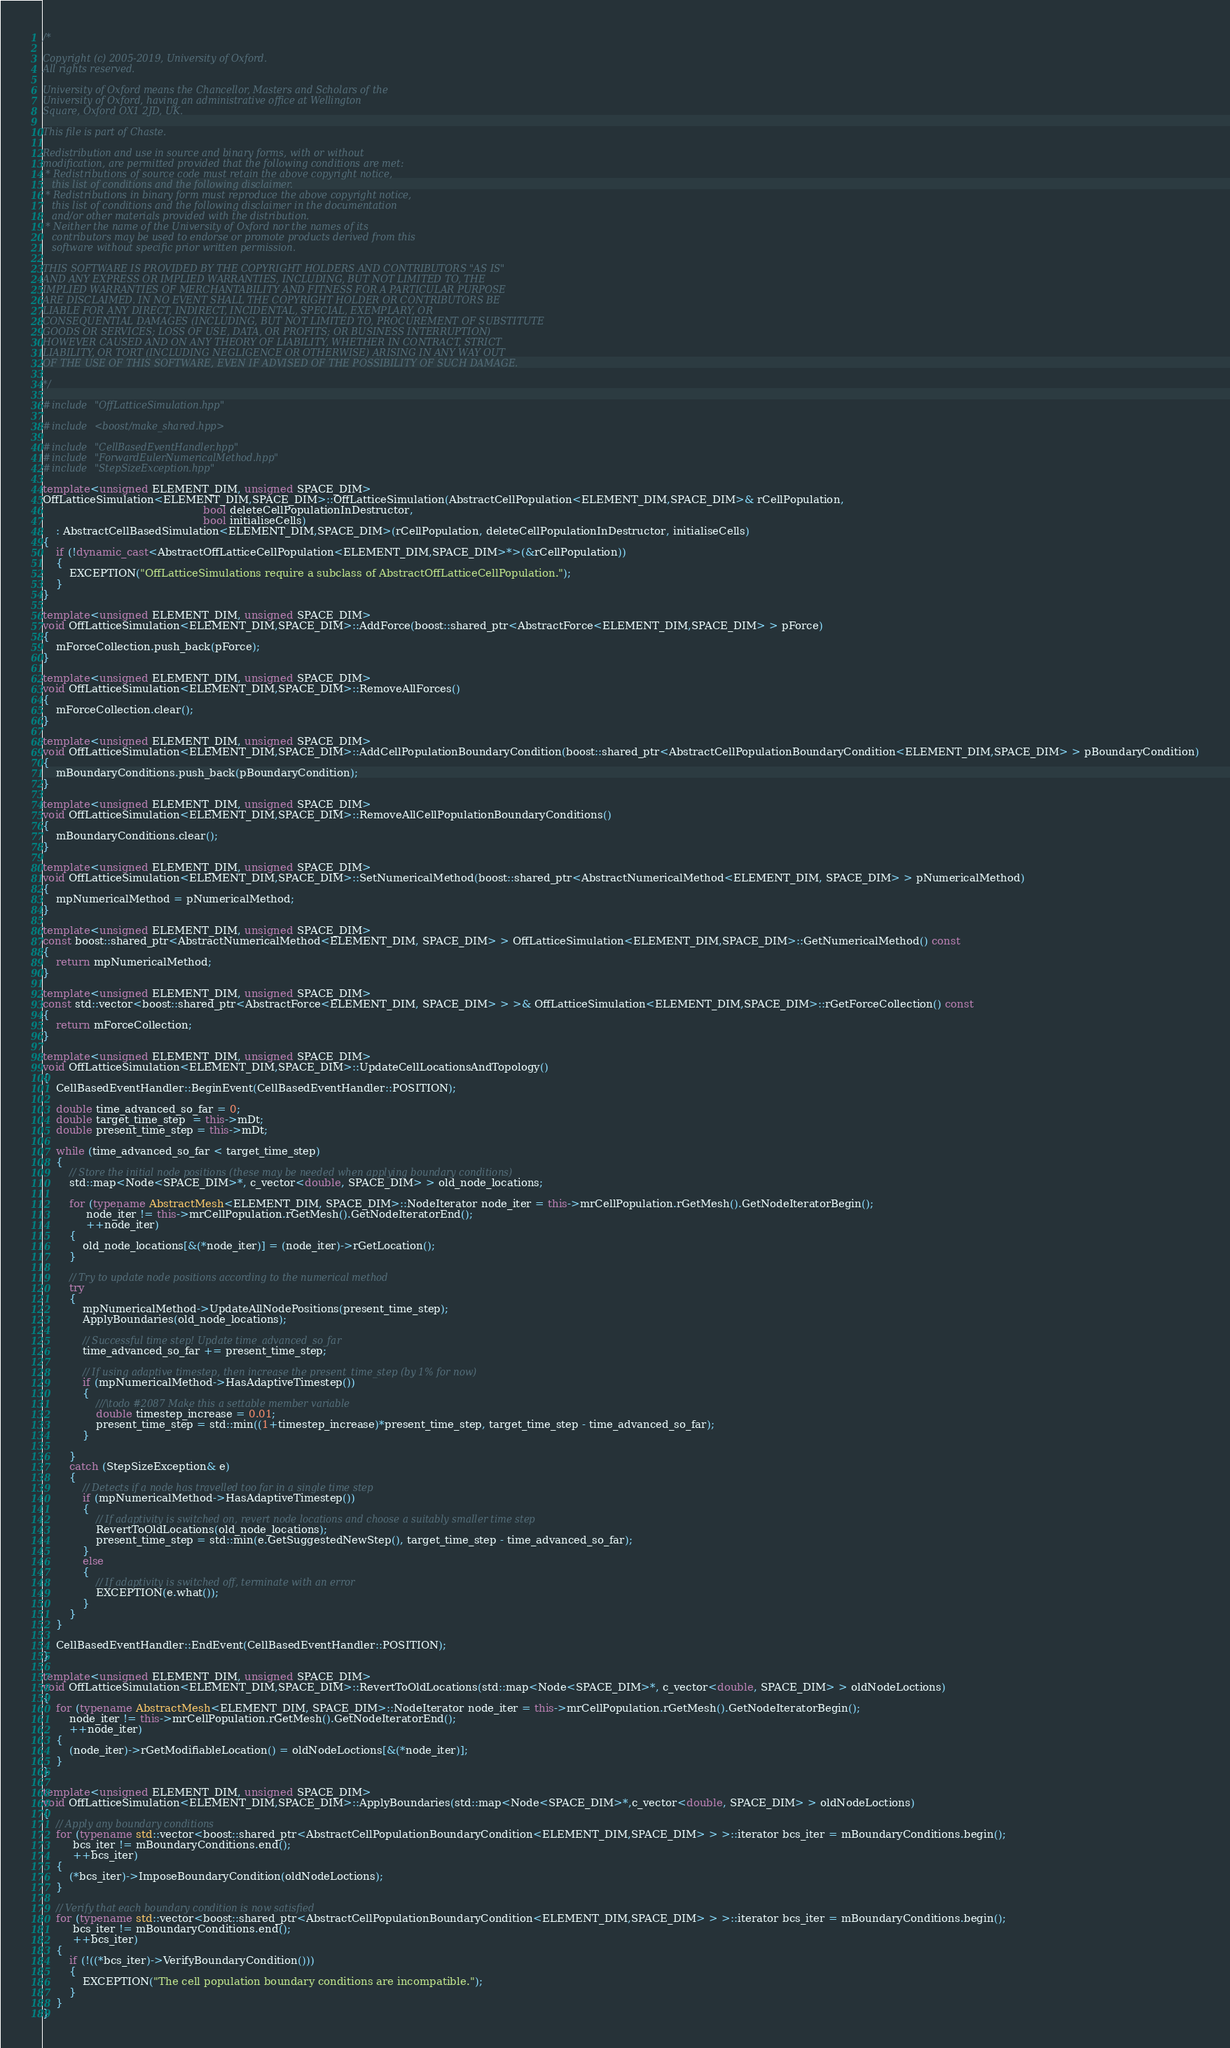<code> <loc_0><loc_0><loc_500><loc_500><_C++_>/*

Copyright (c) 2005-2019, University of Oxford.
All rights reserved.

University of Oxford means the Chancellor, Masters and Scholars of the
University of Oxford, having an administrative office at Wellington
Square, Oxford OX1 2JD, UK.

This file is part of Chaste.

Redistribution and use in source and binary forms, with or without
modification, are permitted provided that the following conditions are met:
 * Redistributions of source code must retain the above copyright notice,
   this list of conditions and the following disclaimer.
 * Redistributions in binary form must reproduce the above copyright notice,
   this list of conditions and the following disclaimer in the documentation
   and/or other materials provided with the distribution.
 * Neither the name of the University of Oxford nor the names of its
   contributors may be used to endorse or promote products derived from this
   software without specific prior written permission.

THIS SOFTWARE IS PROVIDED BY THE COPYRIGHT HOLDERS AND CONTRIBUTORS "AS IS"
AND ANY EXPRESS OR IMPLIED WARRANTIES, INCLUDING, BUT NOT LIMITED TO, THE
IMPLIED WARRANTIES OF MERCHANTABILITY AND FITNESS FOR A PARTICULAR PURPOSE
ARE DISCLAIMED. IN NO EVENT SHALL THE COPYRIGHT HOLDER OR CONTRIBUTORS BE
LIABLE FOR ANY DIRECT, INDIRECT, INCIDENTAL, SPECIAL, EXEMPLARY, OR
CONSEQUENTIAL DAMAGES (INCLUDING, BUT NOT LIMITED TO, PROCUREMENT OF SUBSTITUTE
GOODS OR SERVICES; LOSS OF USE, DATA, OR PROFITS; OR BUSINESS INTERRUPTION)
HOWEVER CAUSED AND ON ANY THEORY OF LIABILITY, WHETHER IN CONTRACT, STRICT
LIABILITY, OR TORT (INCLUDING NEGLIGENCE OR OTHERWISE) ARISING IN ANY WAY OUT
OF THE USE OF THIS SOFTWARE, EVEN IF ADVISED OF THE POSSIBILITY OF SUCH DAMAGE.

*/

#include "OffLatticeSimulation.hpp"

#include <boost/make_shared.hpp>

#include "CellBasedEventHandler.hpp"
#include "ForwardEulerNumericalMethod.hpp"
#include "StepSizeException.hpp"

template<unsigned ELEMENT_DIM, unsigned SPACE_DIM>
OffLatticeSimulation<ELEMENT_DIM,SPACE_DIM>::OffLatticeSimulation(AbstractCellPopulation<ELEMENT_DIM,SPACE_DIM>& rCellPopulation,
                                                bool deleteCellPopulationInDestructor,
                                                bool initialiseCells)
    : AbstractCellBasedSimulation<ELEMENT_DIM,SPACE_DIM>(rCellPopulation, deleteCellPopulationInDestructor, initialiseCells)
{
    if (!dynamic_cast<AbstractOffLatticeCellPopulation<ELEMENT_DIM,SPACE_DIM>*>(&rCellPopulation))
    {
        EXCEPTION("OffLatticeSimulations require a subclass of AbstractOffLatticeCellPopulation.");
    }
}

template<unsigned ELEMENT_DIM, unsigned SPACE_DIM>
void OffLatticeSimulation<ELEMENT_DIM,SPACE_DIM>::AddForce(boost::shared_ptr<AbstractForce<ELEMENT_DIM,SPACE_DIM> > pForce)
{
    mForceCollection.push_back(pForce);
}

template<unsigned ELEMENT_DIM, unsigned SPACE_DIM>
void OffLatticeSimulation<ELEMENT_DIM,SPACE_DIM>::RemoveAllForces()
{
    mForceCollection.clear();
}

template<unsigned ELEMENT_DIM, unsigned SPACE_DIM>
void OffLatticeSimulation<ELEMENT_DIM,SPACE_DIM>::AddCellPopulationBoundaryCondition(boost::shared_ptr<AbstractCellPopulationBoundaryCondition<ELEMENT_DIM,SPACE_DIM> > pBoundaryCondition)
{
    mBoundaryConditions.push_back(pBoundaryCondition);
}

template<unsigned ELEMENT_DIM, unsigned SPACE_DIM>
void OffLatticeSimulation<ELEMENT_DIM,SPACE_DIM>::RemoveAllCellPopulationBoundaryConditions()
{
    mBoundaryConditions.clear();
}

template<unsigned ELEMENT_DIM, unsigned SPACE_DIM>
void OffLatticeSimulation<ELEMENT_DIM,SPACE_DIM>::SetNumericalMethod(boost::shared_ptr<AbstractNumericalMethod<ELEMENT_DIM, SPACE_DIM> > pNumericalMethod)
{
    mpNumericalMethod = pNumericalMethod;
}

template<unsigned ELEMENT_DIM, unsigned SPACE_DIM>
const boost::shared_ptr<AbstractNumericalMethod<ELEMENT_DIM, SPACE_DIM> > OffLatticeSimulation<ELEMENT_DIM,SPACE_DIM>::GetNumericalMethod() const
{
    return mpNumericalMethod;
}

template<unsigned ELEMENT_DIM, unsigned SPACE_DIM>
const std::vector<boost::shared_ptr<AbstractForce<ELEMENT_DIM, SPACE_DIM> > >& OffLatticeSimulation<ELEMENT_DIM,SPACE_DIM>::rGetForceCollection() const
{
    return mForceCollection;
}

template<unsigned ELEMENT_DIM, unsigned SPACE_DIM>
void OffLatticeSimulation<ELEMENT_DIM,SPACE_DIM>::UpdateCellLocationsAndTopology()
{
    CellBasedEventHandler::BeginEvent(CellBasedEventHandler::POSITION);

    double time_advanced_so_far = 0;
    double target_time_step  = this->mDt;
    double present_time_step = this->mDt;

    while (time_advanced_so_far < target_time_step)
    {
        // Store the initial node positions (these may be needed when applying boundary conditions)
        std::map<Node<SPACE_DIM>*, c_vector<double, SPACE_DIM> > old_node_locations;

        for (typename AbstractMesh<ELEMENT_DIM, SPACE_DIM>::NodeIterator node_iter = this->mrCellPopulation.rGetMesh().GetNodeIteratorBegin();
             node_iter != this->mrCellPopulation.rGetMesh().GetNodeIteratorEnd();
             ++node_iter)
        {
            old_node_locations[&(*node_iter)] = (node_iter)->rGetLocation();
        }

        // Try to update node positions according to the numerical method
        try
        {
            mpNumericalMethod->UpdateAllNodePositions(present_time_step);
            ApplyBoundaries(old_node_locations);

            // Successful time step! Update time_advanced_so_far
            time_advanced_so_far += present_time_step;

            // If using adaptive timestep, then increase the present_time_step (by 1% for now)
            if (mpNumericalMethod->HasAdaptiveTimestep())
            {
                ///\todo #2087 Make this a settable member variable
                double timestep_increase = 0.01;
                present_time_step = std::min((1+timestep_increase)*present_time_step, target_time_step - time_advanced_so_far);
            }

        }
        catch (StepSizeException& e)
        {
            // Detects if a node has travelled too far in a single time step
            if (mpNumericalMethod->HasAdaptiveTimestep())
            {
                // If adaptivity is switched on, revert node locations and choose a suitably smaller time step
                RevertToOldLocations(old_node_locations);
                present_time_step = std::min(e.GetSuggestedNewStep(), target_time_step - time_advanced_so_far);
            }
            else
            {
                // If adaptivity is switched off, terminate with an error
                EXCEPTION(e.what());
            }
        }
    }

    CellBasedEventHandler::EndEvent(CellBasedEventHandler::POSITION);
}

template<unsigned ELEMENT_DIM, unsigned SPACE_DIM>
void OffLatticeSimulation<ELEMENT_DIM,SPACE_DIM>::RevertToOldLocations(std::map<Node<SPACE_DIM>*, c_vector<double, SPACE_DIM> > oldNodeLoctions)
{
    for (typename AbstractMesh<ELEMENT_DIM, SPACE_DIM>::NodeIterator node_iter = this->mrCellPopulation.rGetMesh().GetNodeIteratorBegin();
        node_iter != this->mrCellPopulation.rGetMesh().GetNodeIteratorEnd();
        ++node_iter)
    {
        (node_iter)->rGetModifiableLocation() = oldNodeLoctions[&(*node_iter)];
    }
}

template<unsigned ELEMENT_DIM, unsigned SPACE_DIM>
void OffLatticeSimulation<ELEMENT_DIM,SPACE_DIM>::ApplyBoundaries(std::map<Node<SPACE_DIM>*,c_vector<double, SPACE_DIM> > oldNodeLoctions)
{
    // Apply any boundary conditions
    for (typename std::vector<boost::shared_ptr<AbstractCellPopulationBoundaryCondition<ELEMENT_DIM,SPACE_DIM> > >::iterator bcs_iter = mBoundaryConditions.begin();
         bcs_iter != mBoundaryConditions.end();
         ++bcs_iter)
    {
        (*bcs_iter)->ImposeBoundaryCondition(oldNodeLoctions);
    }

    // Verify that each boundary condition is now satisfied
    for (typename std::vector<boost::shared_ptr<AbstractCellPopulationBoundaryCondition<ELEMENT_DIM,SPACE_DIM> > >::iterator bcs_iter = mBoundaryConditions.begin();
         bcs_iter != mBoundaryConditions.end();
         ++bcs_iter)
    {
        if (!((*bcs_iter)->VerifyBoundaryCondition()))
        {
            EXCEPTION("The cell population boundary conditions are incompatible.");
        }
    }
}
</code> 